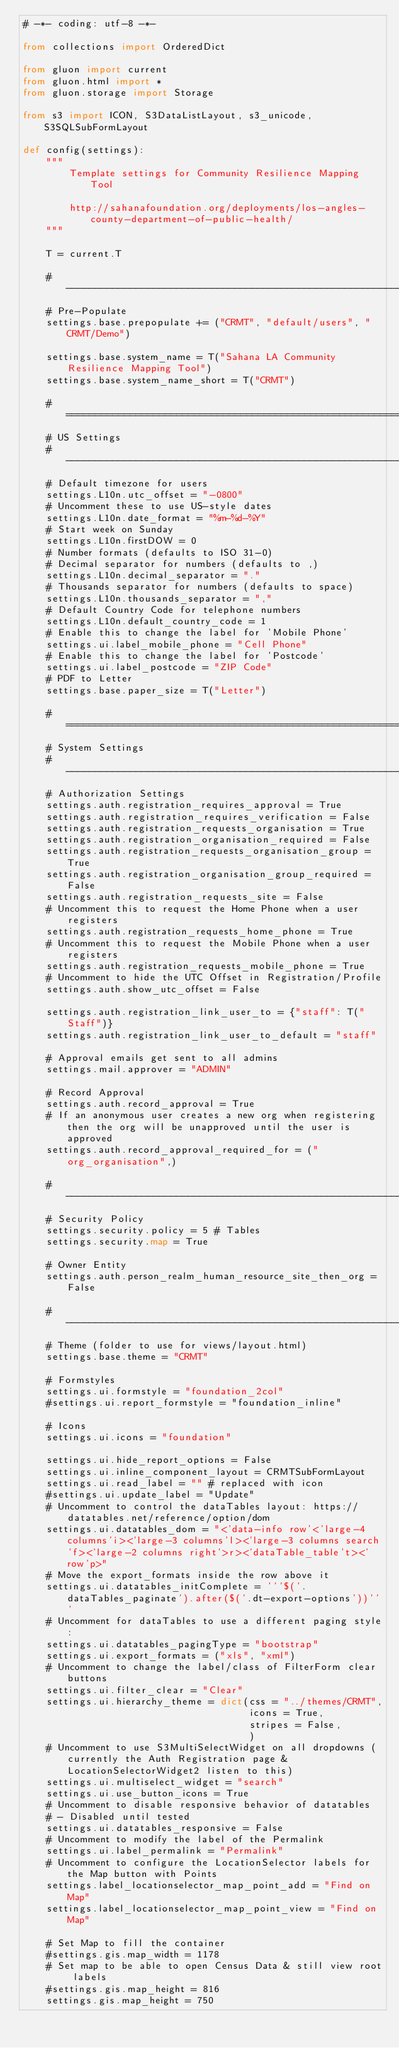Convert code to text. <code><loc_0><loc_0><loc_500><loc_500><_Python_># -*- coding: utf-8 -*-

from collections import OrderedDict

from gluon import current
from gluon.html import *
from gluon.storage import Storage

from s3 import ICON, S3DataListLayout, s3_unicode, S3SQLSubFormLayout

def config(settings):
    """
        Template settings for Community Resilience Mapping Tool

        http://sahanafoundation.org/deployments/los-angles-county-department-of-public-health/
    """

    T = current.T

    # -----------------------------------------------------------------------------
    # Pre-Populate
    settings.base.prepopulate += ("CRMT", "default/users", "CRMT/Demo")

    settings.base.system_name = T("Sahana LA Community Resilience Mapping Tool")
    settings.base.system_name_short = T("CRMT")

    # =============================================================================
    # US Settings
    # -----------------------------------------------------------------------------
    # Default timezone for users
    settings.L10n.utc_offset = "-0800"
    # Uncomment these to use US-style dates
    settings.L10n.date_format = "%m-%d-%Y"
    # Start week on Sunday
    settings.L10n.firstDOW = 0
    # Number formats (defaults to ISO 31-0)
    # Decimal separator for numbers (defaults to ,)
    settings.L10n.decimal_separator = "."
    # Thousands separator for numbers (defaults to space)
    settings.L10n.thousands_separator = ","
    # Default Country Code for telephone numbers
    settings.L10n.default_country_code = 1
    # Enable this to change the label for 'Mobile Phone'
    settings.ui.label_mobile_phone = "Cell Phone"
    # Enable this to change the label for 'Postcode'
    settings.ui.label_postcode = "ZIP Code"
    # PDF to Letter
    settings.base.paper_size = T("Letter")

    # =============================================================================
    # System Settings
    # -----------------------------------------------------------------------------
    # Authorization Settings
    settings.auth.registration_requires_approval = True
    settings.auth.registration_requires_verification = False
    settings.auth.registration_requests_organisation = True
    settings.auth.registration_organisation_required = False
    settings.auth.registration_requests_organisation_group = True
    settings.auth.registration_organisation_group_required = False
    settings.auth.registration_requests_site = False
    # Uncomment this to request the Home Phone when a user registers
    settings.auth.registration_requests_home_phone = True
    # Uncomment this to request the Mobile Phone when a user registers
    settings.auth.registration_requests_mobile_phone = True
    # Uncomment to hide the UTC Offset in Registration/Profile
    settings.auth.show_utc_offset = False

    settings.auth.registration_link_user_to = {"staff": T("Staff")}
    settings.auth.registration_link_user_to_default = "staff"

    # Approval emails get sent to all admins
    settings.mail.approver = "ADMIN"

    # Record Approval
    settings.auth.record_approval = True
    # If an anonymous user creates a new org when registering then the org will be unapproved until the user is approved
    settings.auth.record_approval_required_for = ("org_organisation",)

    # -----------------------------------------------------------------------------
    # Security Policy
    settings.security.policy = 5 # Tables
    settings.security.map = True

    # Owner Entity
    settings.auth.person_realm_human_resource_site_then_org = False

    # -----------------------------------------------------------------------------
    # Theme (folder to use for views/layout.html)
    settings.base.theme = "CRMT"

    # Formstyles
    settings.ui.formstyle = "foundation_2col"
    #settings.ui.report_formstyle = "foundation_inline"

    # Icons
    settings.ui.icons = "foundation"

    settings.ui.hide_report_options = False
    settings.ui.inline_component_layout = CRMTSubFormLayout
    settings.ui.read_label = "" # replaced with icon
    #settings.ui.update_label = "Update"
    # Uncomment to control the dataTables layout: https://datatables.net/reference/option/dom
    settings.ui.datatables_dom = "<'data-info row'<'large-4 columns'i><'large-3 columns'l><'large-3 columns search'f><'large-2 columns right'>r><'dataTable_table't><'row'p>"
    # Move the export_formats inside the row above it
    settings.ui.datatables_initComplete = '''$('.dataTables_paginate').after($('.dt-export-options'))'''
    # Uncomment for dataTables to use a different paging style:
    settings.ui.datatables_pagingType = "bootstrap"
    settings.ui.export_formats = ("xls", "xml")
    # Uncomment to change the label/class of FilterForm clear buttons
    settings.ui.filter_clear = "Clear"
    settings.ui.hierarchy_theme = dict(css = "../themes/CRMT",
                                       icons = True,
                                       stripes = False,
                                       )
    # Uncomment to use S3MultiSelectWidget on all dropdowns (currently the Auth Registration page & LocationSelectorWidget2 listen to this)
    settings.ui.multiselect_widget = "search"
    settings.ui.use_button_icons = True
    # Uncomment to disable responsive behavior of datatables
    # - Disabled until tested
    settings.ui.datatables_responsive = False
    # Uncomment to modify the label of the Permalink
    settings.ui.label_permalink = "Permalink"
    # Uncomment to configure the LocationSelector labels for the Map button with Points
    settings.label_locationselector_map_point_add = "Find on Map"
    settings.label_locationselector_map_point_view = "Find on Map"

    # Set Map to fill the container
    #settings.gis.map_width = 1178
    # Set map to be able to open Census Data & still view root labels
    #settings.gis.map_height = 816
    settings.gis.map_height = 750
</code> 